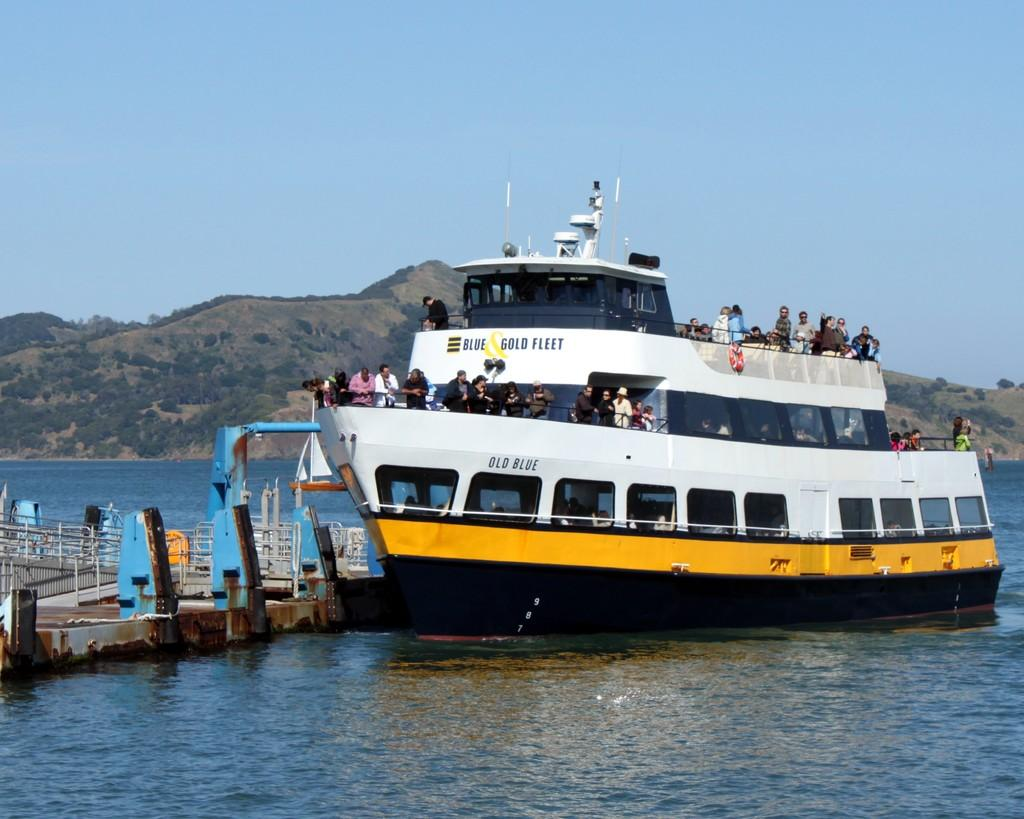What is the main subject of the image? The main subject of the image is a ship. How many people are on the ship? The ship has many people on it. What colors can be seen on the ship? The ship is white and yellow in color. What is at the bottom of the image? There is water at the bottom of the image. What can be seen in the background of the image? There are mountains in the background of the image. What type of jelly is being used to hold the ship in place in the image? There is no jelly present in the image, and the ship is not being held in place by any such substance. 